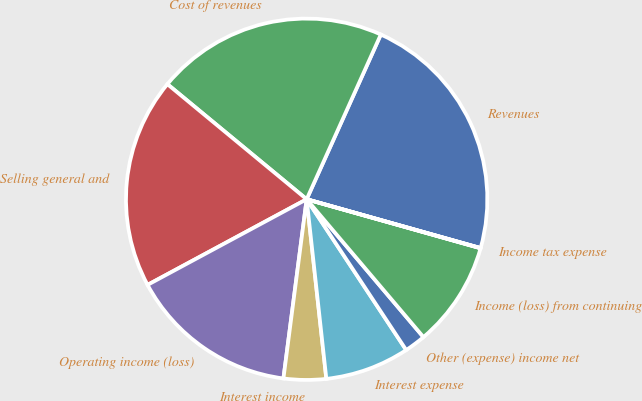Convert chart. <chart><loc_0><loc_0><loc_500><loc_500><pie_chart><fcel>Revenues<fcel>Cost of revenues<fcel>Selling general and<fcel>Operating income (loss)<fcel>Interest income<fcel>Interest expense<fcel>Other (expense) income net<fcel>Income (loss) from continuing<fcel>Income tax expense<nl><fcel>22.62%<fcel>20.74%<fcel>18.85%<fcel>15.09%<fcel>3.79%<fcel>7.55%<fcel>1.9%<fcel>9.44%<fcel>0.02%<nl></chart> 